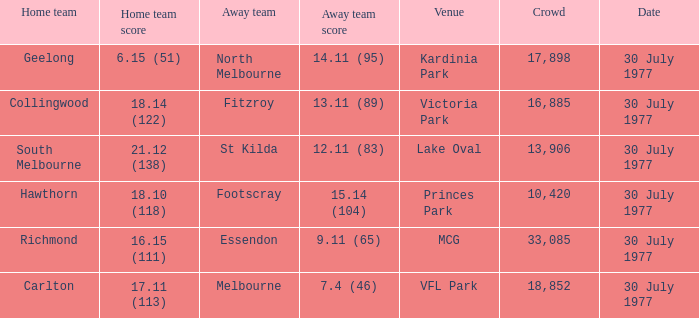11 (65)? Richmond. 